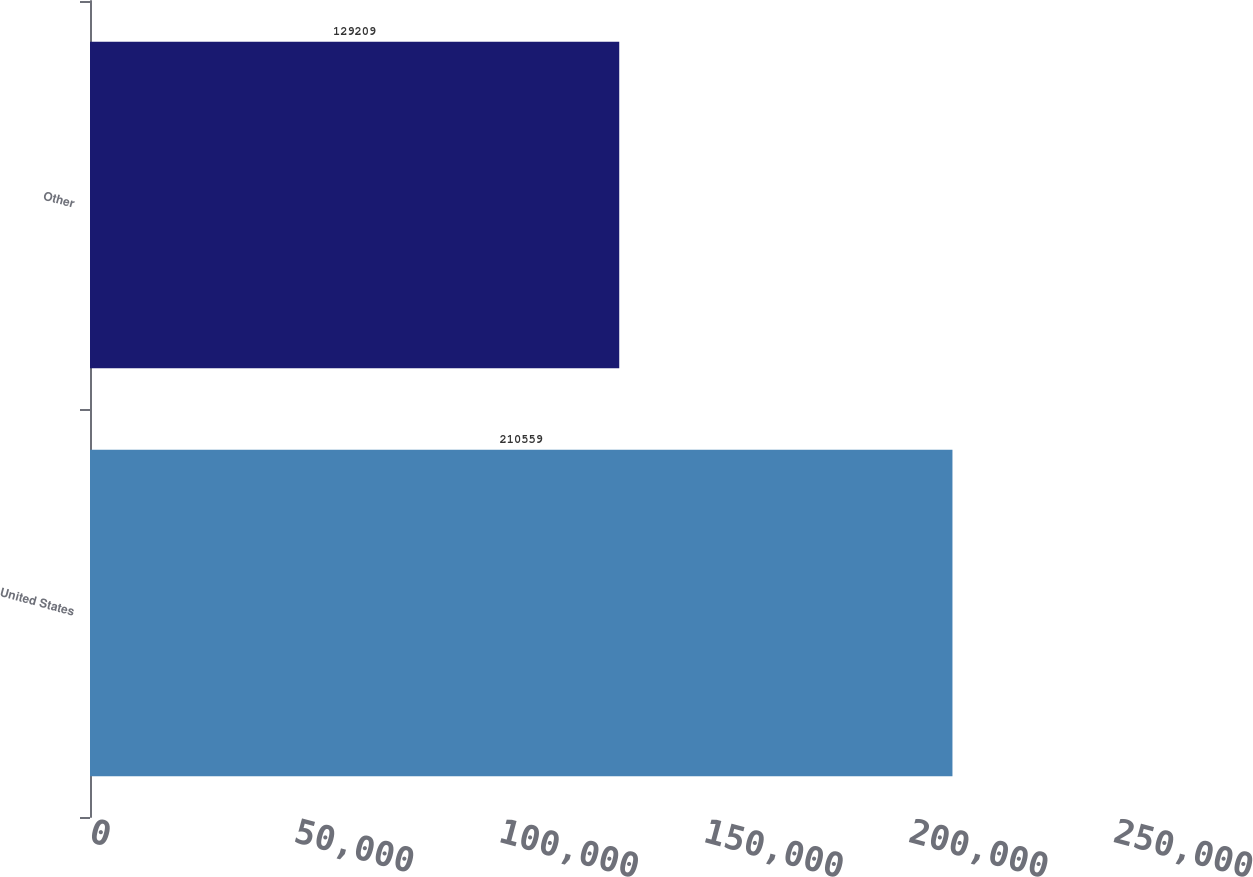Convert chart to OTSL. <chart><loc_0><loc_0><loc_500><loc_500><bar_chart><fcel>United States<fcel>Other<nl><fcel>210559<fcel>129209<nl></chart> 